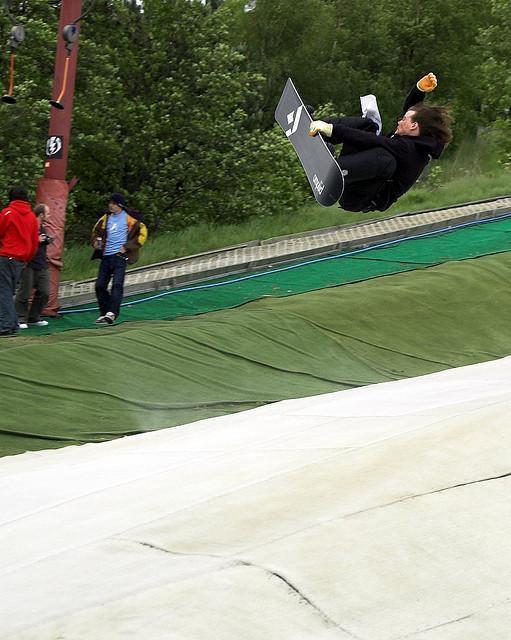How many people are in the picture?
Give a very brief answer. 4. 